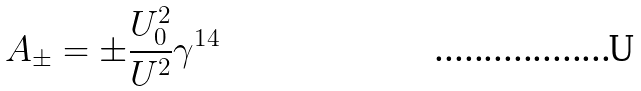<formula> <loc_0><loc_0><loc_500><loc_500>A _ { \pm } = \pm \frac { U _ { 0 } ^ { 2 } } { U ^ { 2 } } \gamma ^ { 1 4 }</formula> 